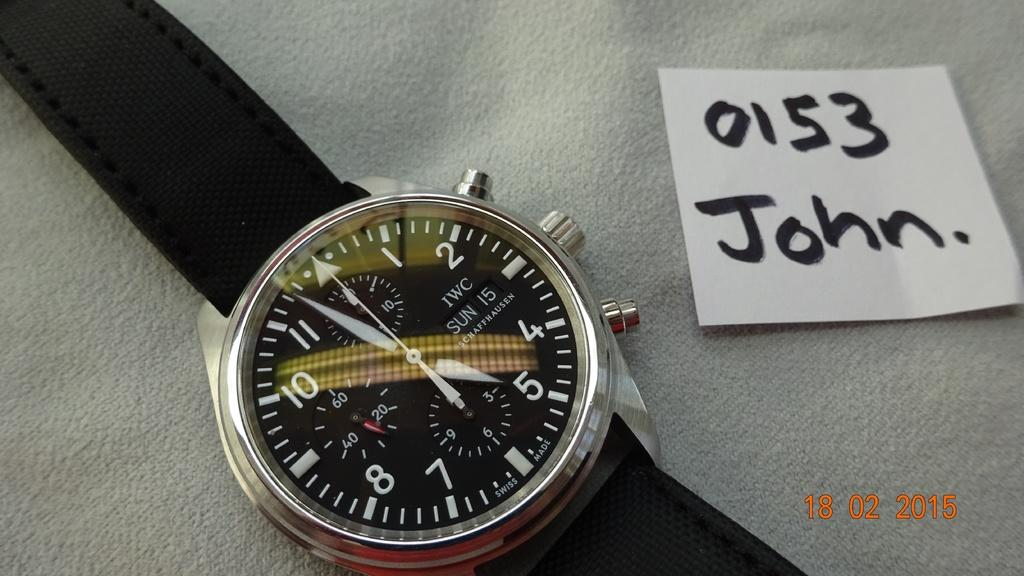<image>
Render a clear and concise summary of the photo. A watch is sitting next to a note that says 0153 John. 